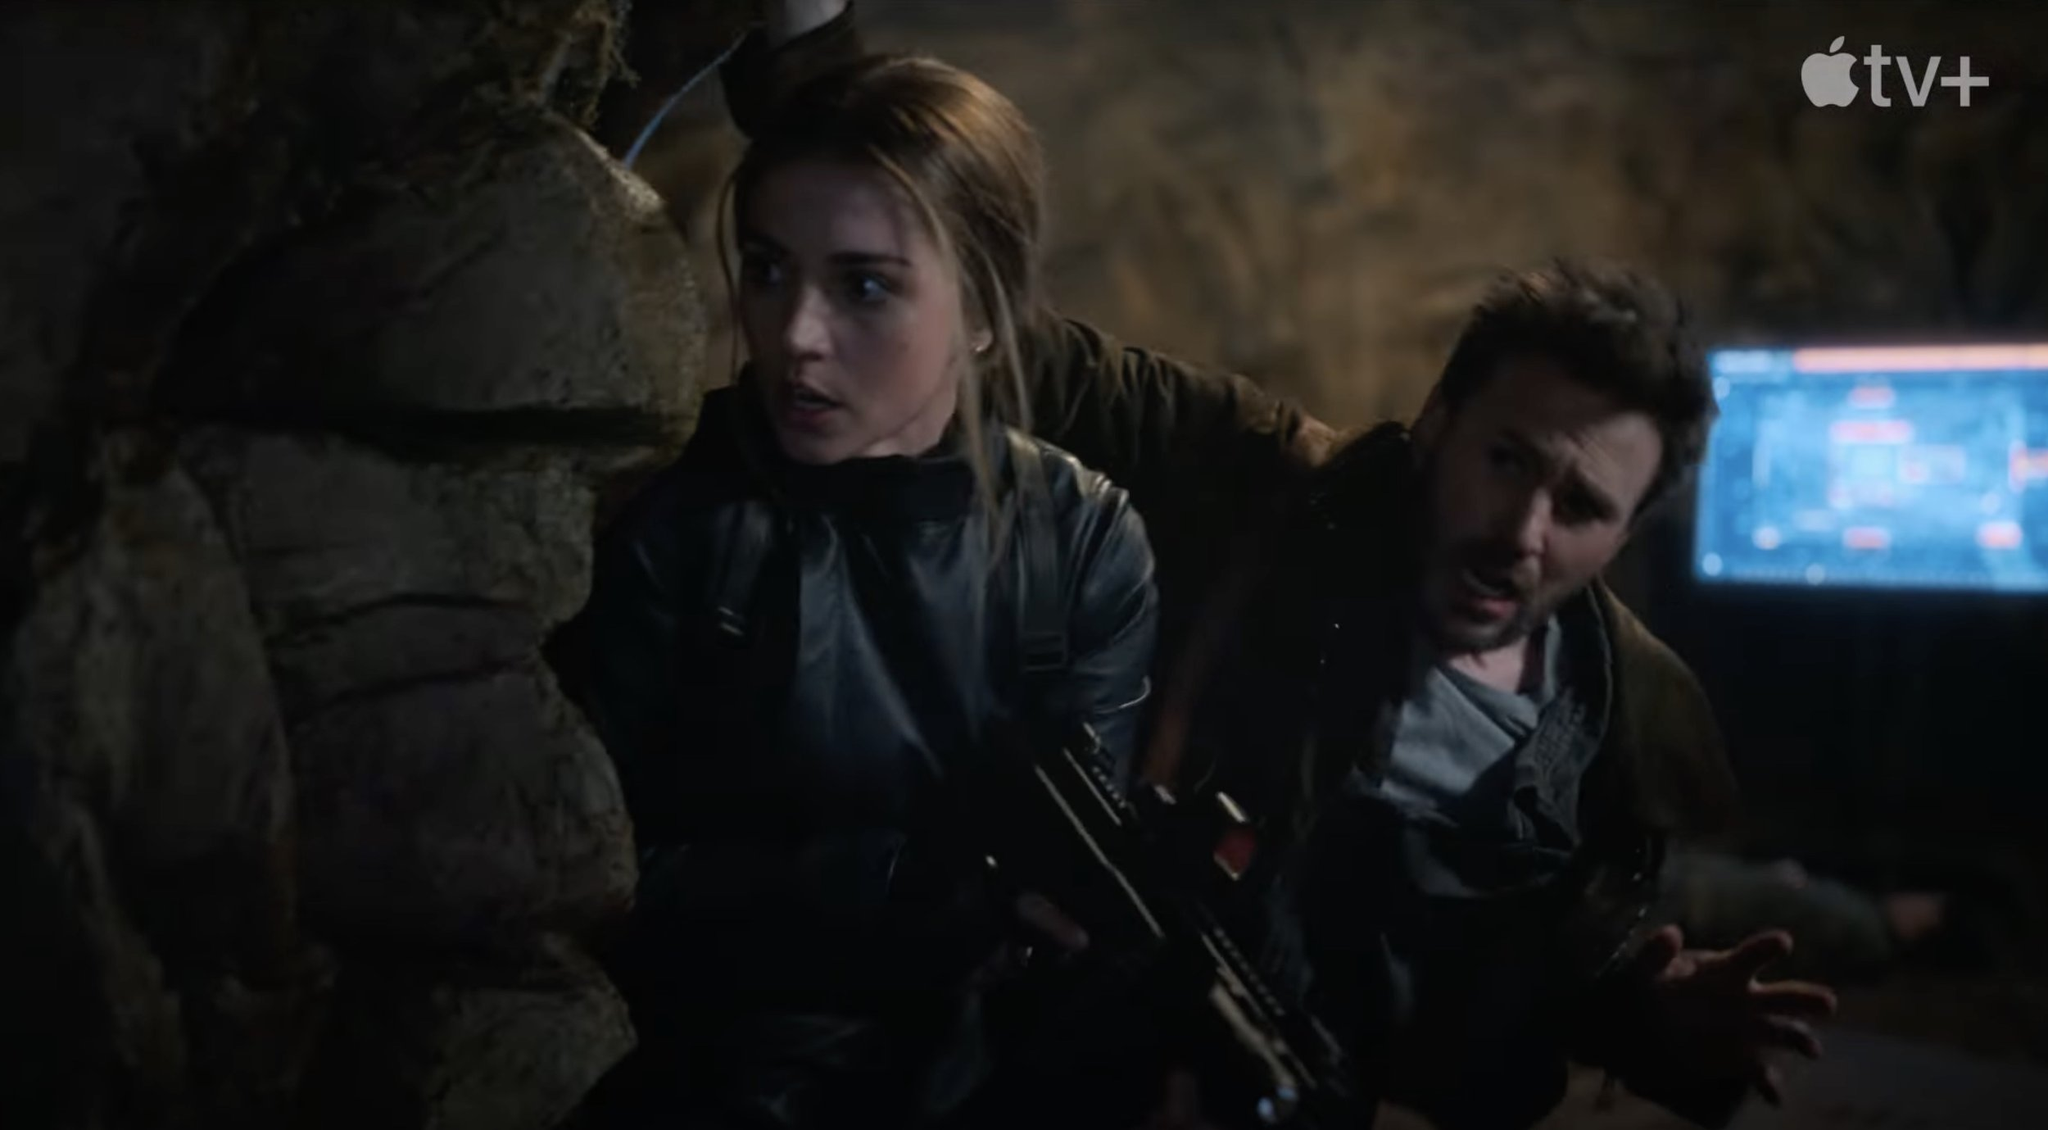Describe the emotional state of the characters. The characters in the scene exude a mixture of tension and determination. The female character, with her eyes wide and her grip firm on her firearm, portrays vigilance and readiness. The male character, leaning forward with a concerned expression, seems anxious yet resolved. Both are evidently prepared for an imminent threat, reflecting a state of high alertness and urgency. Their body language and focused demeanor emphasize the gravity of their situation. What could be their backstory leading up to this moment? Leading up to this intense moment, it's plausible to imagine that the characters have been on the run or engaged in an undercover mission for some time. Perhaps they are part of a covert task force or a duo of spies who have uncovered critical information about a dangerous enemy. Their journey may have involved escaping narrow threats, gathering intelligence, and preparing for a pivotal confrontation. The scene suggests they are now on the verge of a crucial showdown, possibly involving stopping a significant threat or retrieving vital information that could change the course of their mission. What wild and imaginative scenario could explain this image? Imagine a world where ancient caverns hide interdimensional portals, guarded by a secret society of time travelers. These characters, once ordinary people, stumbled upon a mysterious artifact that catapulted them into this hidden reality. Now, they are tasked with preventing a catastrophic event orchestrated by rogue time travelers. The cave serves as a nexus point of multiple timelines, and the computer screen is a sophisticated temporal device showing the convergence of these timelines. Their mission is to find the right moment to intervene without collapsing the fabric of time, while evading traps set by their adversaries. 